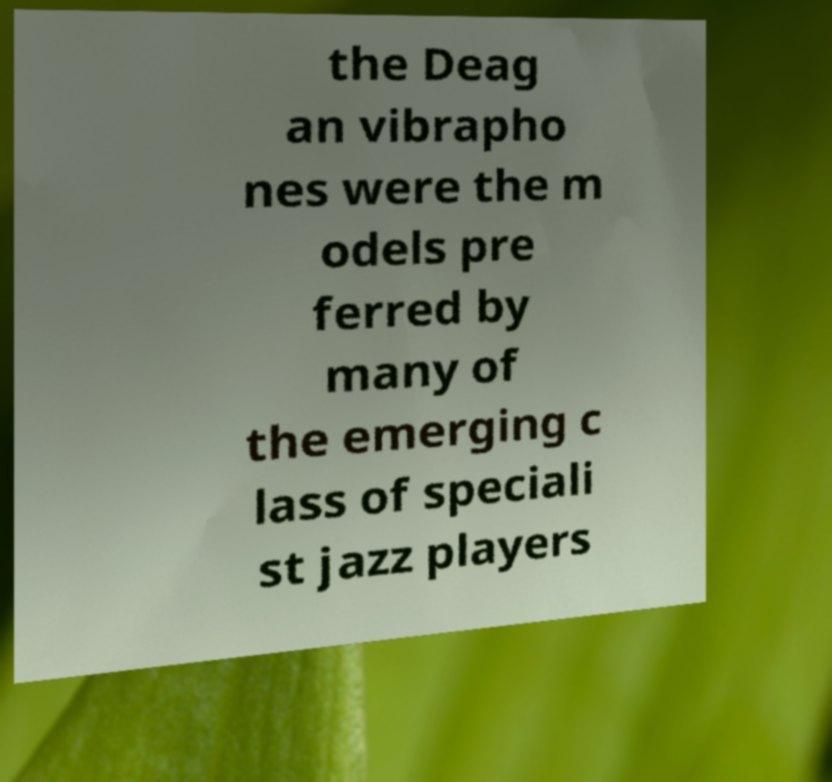I need the written content from this picture converted into text. Can you do that? the Deag an vibrapho nes were the m odels pre ferred by many of the emerging c lass of speciali st jazz players 